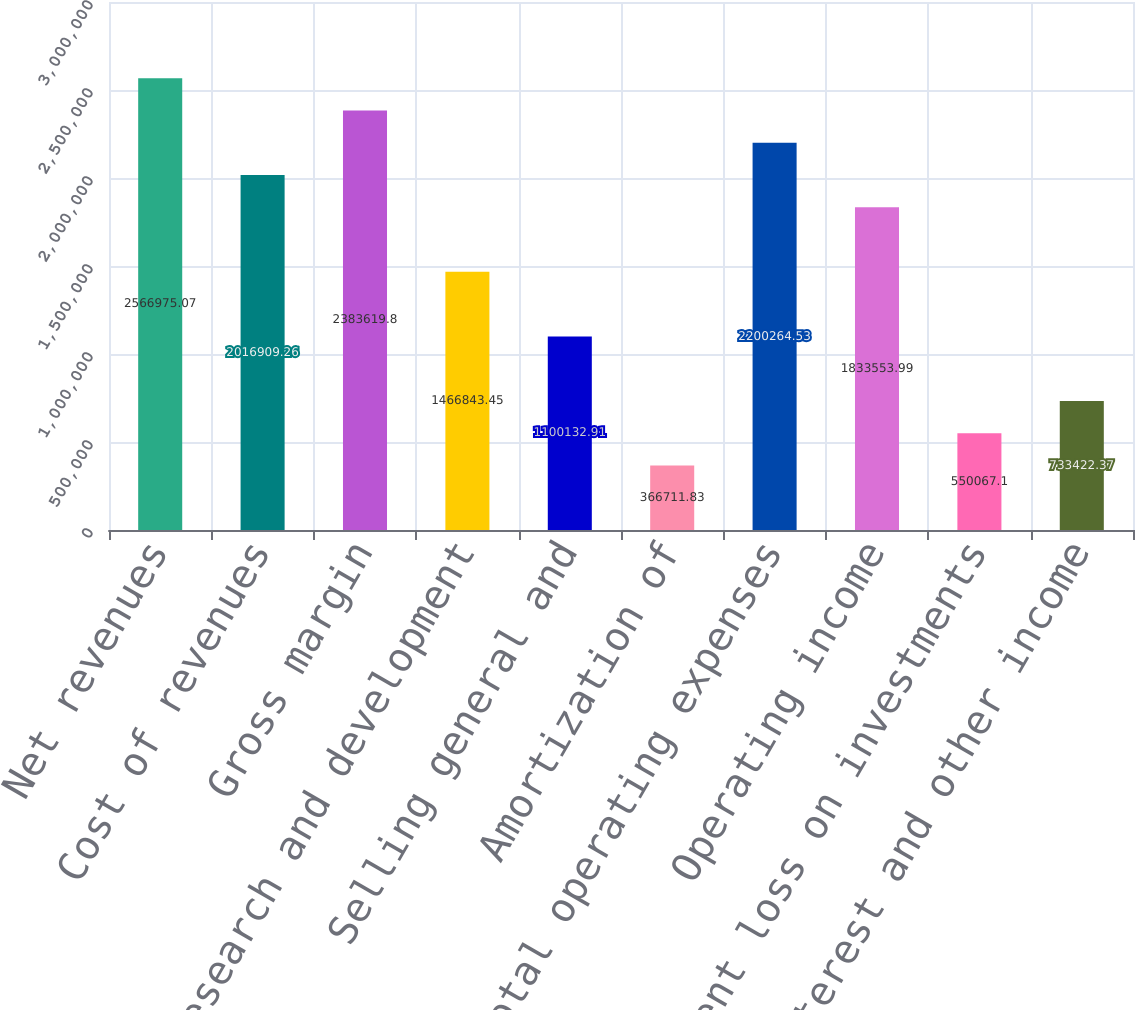Convert chart to OTSL. <chart><loc_0><loc_0><loc_500><loc_500><bar_chart><fcel>Net revenues<fcel>Cost of revenues<fcel>Gross margin<fcel>Research and development<fcel>Selling general and<fcel>Amortization of<fcel>Total operating expenses<fcel>Operating income<fcel>Impairment loss on investments<fcel>Interest and other income<nl><fcel>2.56698e+06<fcel>2.01691e+06<fcel>2.38362e+06<fcel>1.46684e+06<fcel>1.10013e+06<fcel>366712<fcel>2.20026e+06<fcel>1.83355e+06<fcel>550067<fcel>733422<nl></chart> 